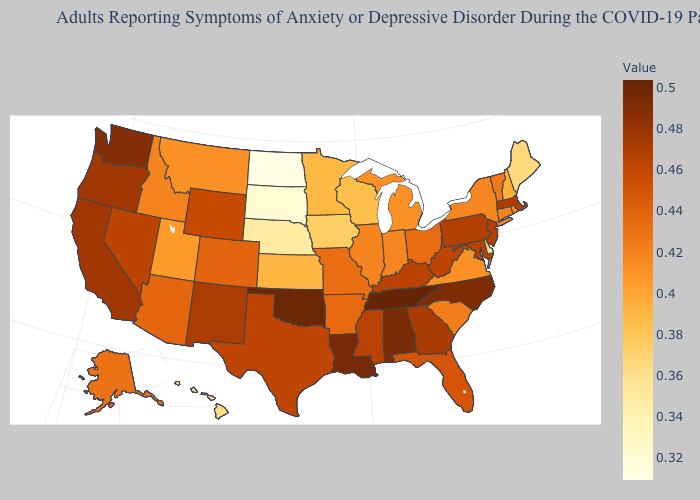Does New Mexico have the lowest value in the West?
Concise answer only. No. Is the legend a continuous bar?
Concise answer only. Yes. Among the states that border Louisiana , which have the lowest value?
Write a very short answer. Arkansas. Among the states that border Georgia , does North Carolina have the lowest value?
Keep it brief. No. Does New Mexico have the highest value in the USA?
Concise answer only. No. Does Minnesota have a lower value than Connecticut?
Keep it brief. Yes. Which states have the highest value in the USA?
Be succinct. Tennessee. Does Hawaii have the highest value in the USA?
Short answer required. No. 